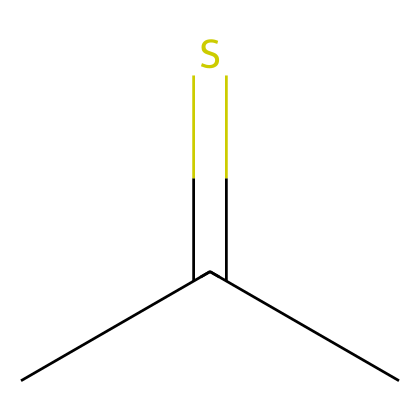what is the name of this chemical? The SMILES representation shows the compound with the structure CC(C)=S, which identifies it as thioacetone.
Answer: thioacetone how many carbon atoms are present in this chemical? The structure CC(C)=S indicates there are three carbon atoms present in the chain.
Answer: three how many hydrogen atoms does this chemical contain? Analyzing the structure CC(C)=S, each carbon contributes a certain number of hydrogens, leading to a total of six hydrogens in thioacetone.
Answer: six what is the functional group in this chemical? The presence of a sulfur atom in the structure CC(C)=S signifies that the functional group is a thioether, in this case, due to the sulfur being part of a carbon chain.
Answer: thioether is this chemical polar or nonpolar? Given the sulfur atom's presence and the structure's symmetry, thioacetone leans towards being polar due to the electronegative sulfur affecting the electron distribution.
Answer: polar 